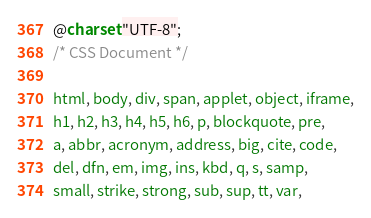<code> <loc_0><loc_0><loc_500><loc_500><_CSS_>@charset "UTF-8";
/* CSS Document */

html, body, div, span, applet, object, iframe,
h1, h2, h3, h4, h5, h6, p, blockquote, pre,
a, abbr, acronym, address, big, cite, code,
del, dfn, em, img, ins, kbd, q, s, samp,
small, strike, strong, sub, sup, tt, var,</code> 